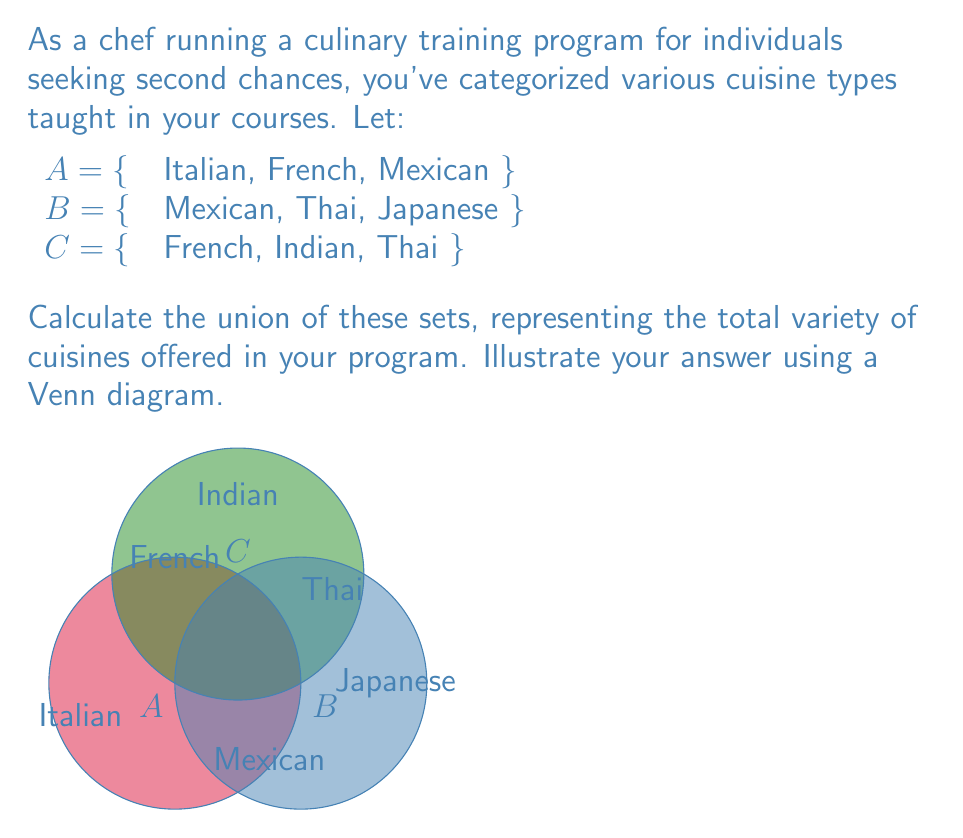Help me with this question. To calculate the union of sets A, B, and C, we need to list all unique elements that appear in at least one of the sets. Let's approach this step-by-step:

1) First, let's list all elements from set A:
   Italian, French, Mexican

2) Now, let's add any new elements from set B:
   Italian, French, Mexican, Thai, Japanese

3) Finally, let's add any new elements from set C:
   Italian, French, Mexican, Thai, Japanese, Indian

4) We can represent this mathematically as:
   $$A \cup B \cup C = \{x | x \in A \text{ or } x \in B \text{ or } x \in C\}$$

5) In set notation, our final union is:
   $$A \cup B \cup C = \{Italian, French, Mexican, Thai, Japanese, Indian\}$$

The Venn diagram in the question visually represents this union, with each cuisine type appearing in at least one of the circles.
Answer: $$\{Italian, French, Mexican, Thai, Japanese, Indian\}$$ 